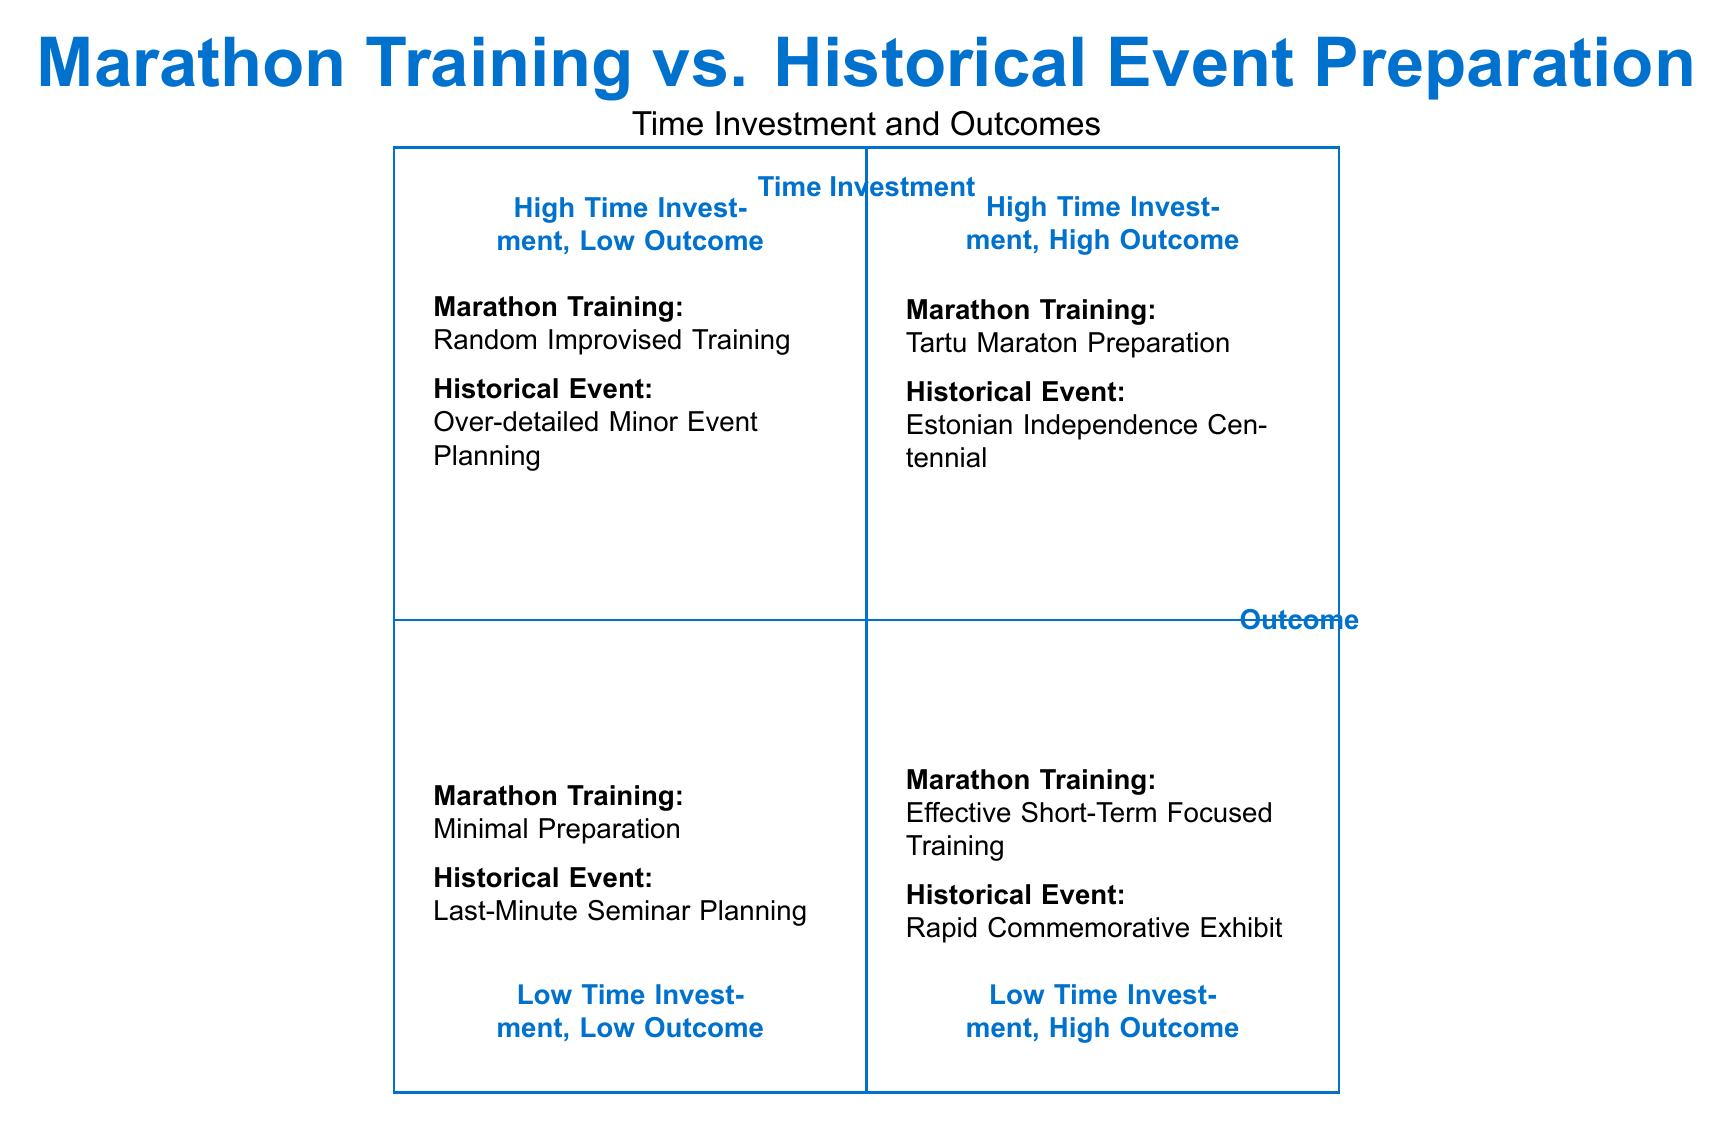What are the two elements in Q1? The two elements in Q1, which represents High Time Investment and High Outcome, are "Marathon Training: Tartu Maraton Preparation" and "Historical Event Preparation: Organizing Estonian Independence Centennial."
Answer: Tartu Maraton Preparation, Organizing Estonian Independence Centennial How many elements are in Q4? Q4 is labeled Low Time Investment, Low Outcome, and it contains two elements: "Marathon Training: Minimal Preparation" and "Historical Event Preparation: Last-Minute Seminar Planning." Therefore, the total number of elements in Q4 is 2.
Answer: 2 Which historical event preparation has high time investment and low outcome? In the quadrant representing high time investment and low outcome (Q2), the historical event preparation listed is "Over-detailed Minor Event Planning," which highlights an inefficient use of time leading to poor outcomes.
Answer: Over-detailed Minor Event Planning In which quadrant is "Effective Short-Term Focused Training" located? "Effective Short-Term Focused Training" is positioned in the bottom right quadrant, which is labeled Low Time Investment, High Outcome (Q3). This indicates that this training method requires minimal time for a potentially high performance outcome.
Answer: Q3 What can be inferred about "Minimal Preparation" in terms of expected outcomes? "Minimal Preparation," located in Q4 (Low Time Investment, Low Outcome), implies that without adequate preparation, the expected outcomes will be poor, as indicated by the description of the inability to complete even a 10k run.
Answer: Poor outcomes 